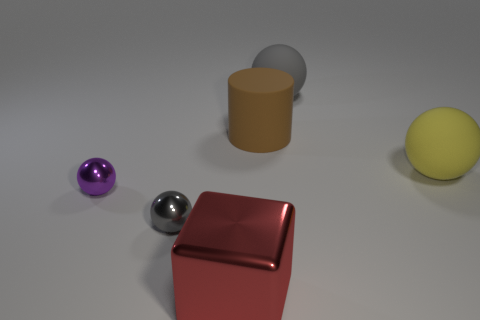Add 3 small red things. How many objects exist? 9 Subtract all small gray balls. How many balls are left? 3 Subtract all purple spheres. How many spheres are left? 3 Subtract all blue cylinders. How many gray balls are left? 2 Subtract 3 spheres. How many spheres are left? 1 Subtract all big matte balls. Subtract all yellow balls. How many objects are left? 3 Add 6 gray balls. How many gray balls are left? 8 Add 6 large metal cubes. How many large metal cubes exist? 7 Subtract 0 green spheres. How many objects are left? 6 Subtract all cubes. How many objects are left? 5 